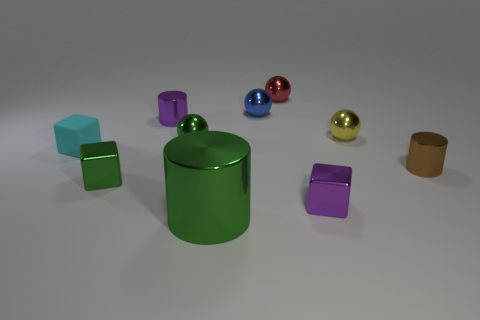There is a cylinder to the left of the green shiny sphere; is it the same size as the yellow ball?
Your answer should be very brief. Yes. What number of matte objects are big red cylinders or cyan objects?
Your response must be concise. 1. What is the size of the metal block on the right side of the red ball?
Offer a very short reply. Small. Does the big green shiny thing have the same shape as the brown shiny object?
Offer a terse response. Yes. What number of small things are either brown rubber balls or red metallic objects?
Your response must be concise. 1. There is a blue ball; are there any small balls to the left of it?
Your answer should be very brief. Yes. Are there the same number of metallic cylinders that are behind the small brown object and blue metal cylinders?
Make the answer very short. No. What is the size of the purple metal thing that is the same shape as the tiny brown shiny object?
Offer a very short reply. Small. Is the shape of the rubber object the same as the tiny purple thing to the right of the large green metal cylinder?
Keep it short and to the point. Yes. There is a cylinder that is in front of the small shiny cylinder to the right of the tiny red object; what is its size?
Offer a very short reply. Large. 